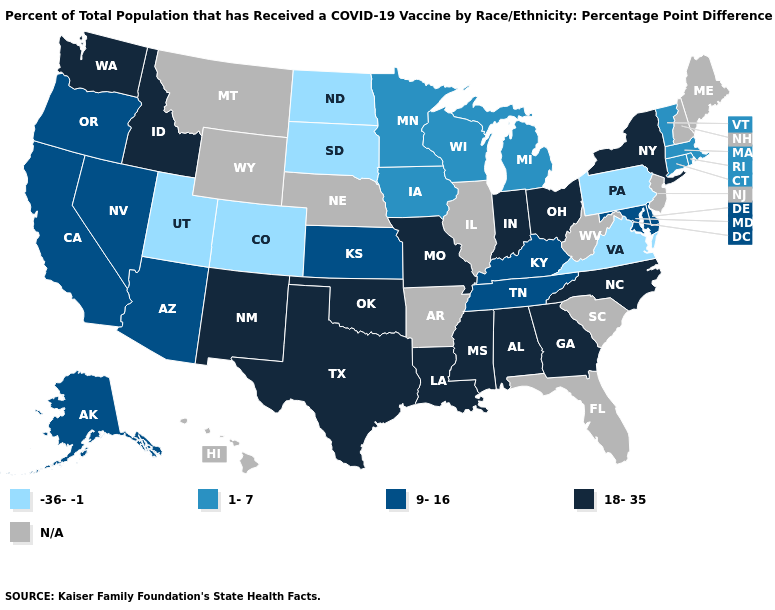What is the lowest value in states that border Pennsylvania?
Write a very short answer. 9-16. Name the states that have a value in the range N/A?
Answer briefly. Arkansas, Florida, Hawaii, Illinois, Maine, Montana, Nebraska, New Hampshire, New Jersey, South Carolina, West Virginia, Wyoming. What is the highest value in the USA?
Keep it brief. 18-35. Name the states that have a value in the range 18-35?
Write a very short answer. Alabama, Georgia, Idaho, Indiana, Louisiana, Mississippi, Missouri, New Mexico, New York, North Carolina, Ohio, Oklahoma, Texas, Washington. What is the lowest value in the MidWest?
Answer briefly. -36--1. Name the states that have a value in the range 9-16?
Quick response, please. Alaska, Arizona, California, Delaware, Kansas, Kentucky, Maryland, Nevada, Oregon, Tennessee. What is the value of Florida?
Answer briefly. N/A. Among the states that border South Dakota , does North Dakota have the lowest value?
Give a very brief answer. Yes. Which states have the highest value in the USA?
Short answer required. Alabama, Georgia, Idaho, Indiana, Louisiana, Mississippi, Missouri, New Mexico, New York, North Carolina, Ohio, Oklahoma, Texas, Washington. Name the states that have a value in the range -36--1?
Write a very short answer. Colorado, North Dakota, Pennsylvania, South Dakota, Utah, Virginia. What is the value of Nebraska?
Concise answer only. N/A. What is the value of Iowa?
Give a very brief answer. 1-7. Among the states that border Mississippi , does Alabama have the lowest value?
Be succinct. No. What is the value of Indiana?
Quick response, please. 18-35. What is the lowest value in states that border Minnesota?
Concise answer only. -36--1. 